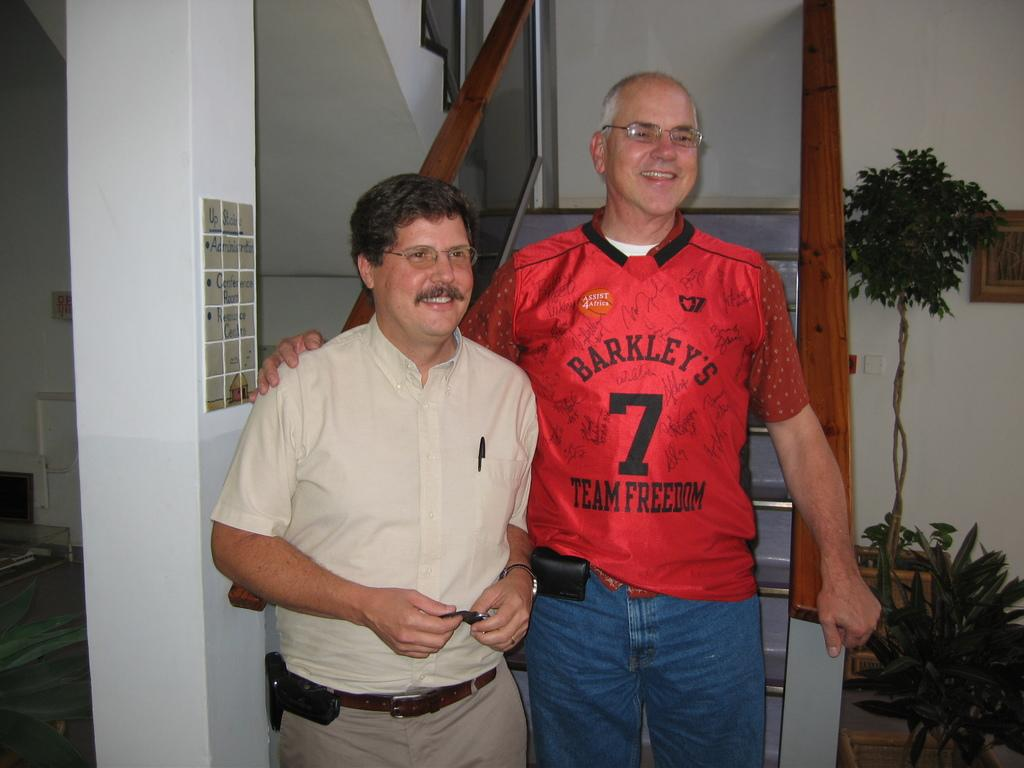What can be seen in the image? There are men standing in the image. What are the men wearing? The men are wearing spectacles. What architectural feature is visible in the background of the image? There are stairs visible in the background of the image. What type of island can be seen in the background of the image? There is no island present in the image; the background features stairs. 